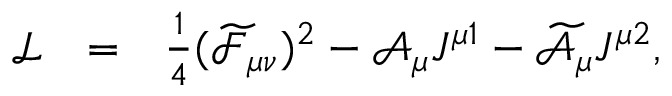<formula> <loc_0><loc_0><loc_500><loc_500>\begin{array} { l l l } { { \mathcal { L } } } & { = } & { { \frac { 1 } { 4 } ( \widetilde { \mathcal { F } } _ { \mu \nu } ) ^ { 2 } - \mathcal { A } _ { \mu } J ^ { \mu 1 } - \widetilde { \mathcal { A } } _ { \mu } J ^ { \mu 2 } , } } \end{array}</formula> 